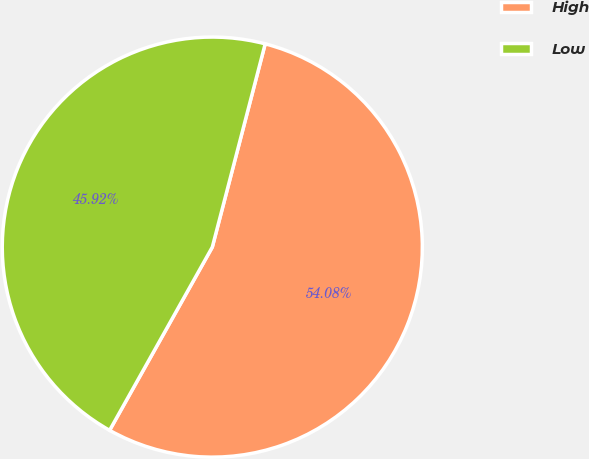Convert chart to OTSL. <chart><loc_0><loc_0><loc_500><loc_500><pie_chart><fcel>High<fcel>Low<nl><fcel>54.08%<fcel>45.92%<nl></chart> 